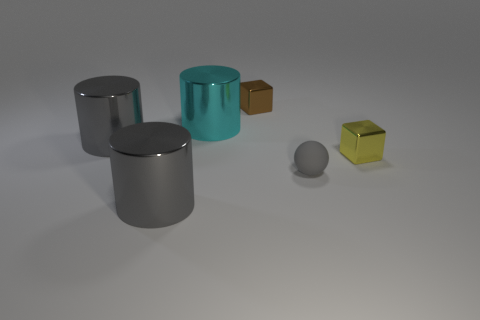What material is the yellow block?
Ensure brevity in your answer.  Metal. Is there anything else that is the same color as the matte ball?
Offer a terse response. Yes. Does the small gray thing have the same shape as the big cyan object?
Ensure brevity in your answer.  No. How big is the gray cylinder in front of the tiny metallic block in front of the big cyan shiny thing that is behind the yellow cube?
Ensure brevity in your answer.  Large. How many other objects are there of the same material as the tiny brown cube?
Provide a short and direct response. 4. There is a small block in front of the cyan cylinder; what is its color?
Offer a terse response. Yellow. The block to the right of the block that is behind the small shiny object that is in front of the cyan metal thing is made of what material?
Offer a terse response. Metal. Are there any other large things of the same shape as the cyan object?
Give a very brief answer. Yes. There is a yellow shiny thing that is the same size as the brown shiny cube; what is its shape?
Provide a short and direct response. Cube. How many gray objects are both in front of the small gray sphere and to the right of the tiny brown metal object?
Your answer should be very brief. 0. 